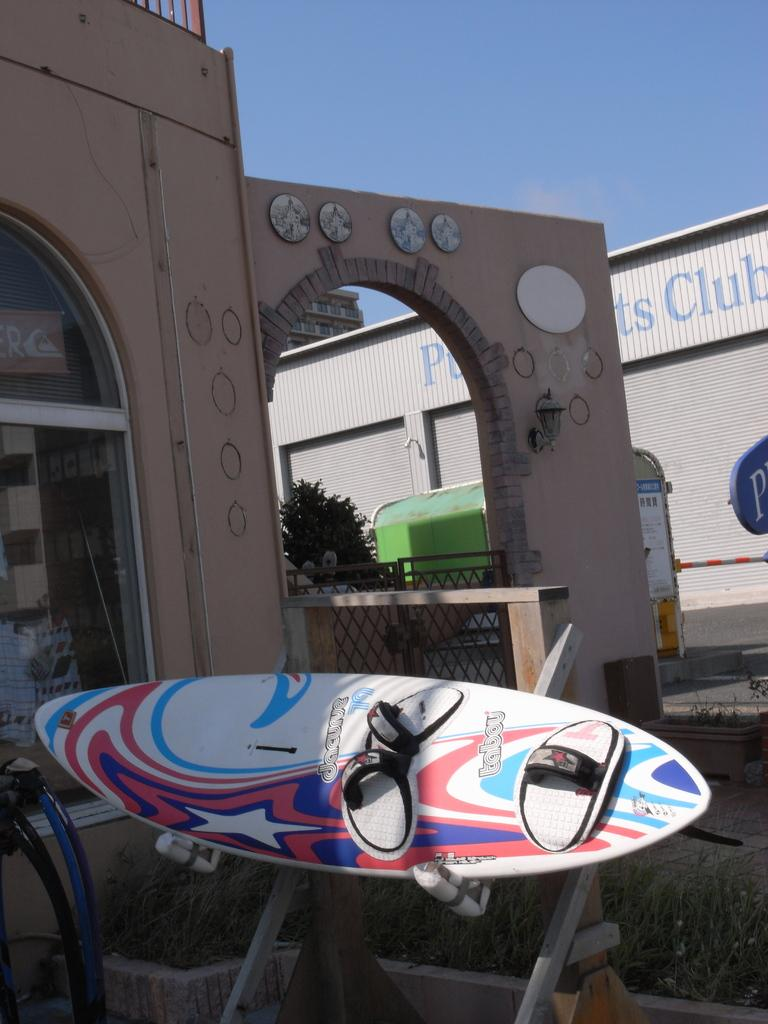What is the main object in the foreground of the image? There is a surfing board in the image. What can be seen in the distance behind the surfing board? There are buildings in the background of the image. What is happening on the road in the background of the image? Vehicles are moving on the road in the background of the image. What part of the natural environment is visible in the image? The sky is visible in the image. Can you touch the turkey that is flying in the sky in the image? There is no turkey present in the image, and therefore it cannot be touched or flown in the sky. 